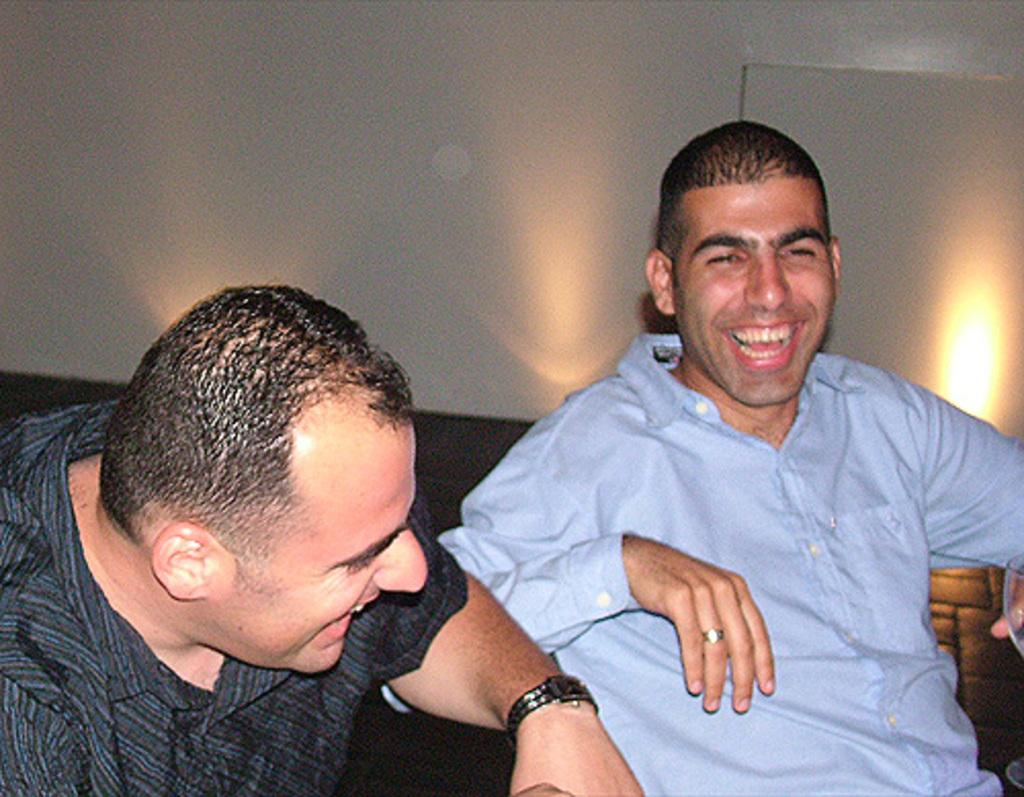How many people are in the image? There are two persons in the image. What expressions do the people have in the image? The two persons are smiling. What is visible in the background of the image? There is a wall in the image. What type of rock can be seen in the image? There is no rock present in the image. How many sheep are visible in the image? There are no sheep present in the image. 